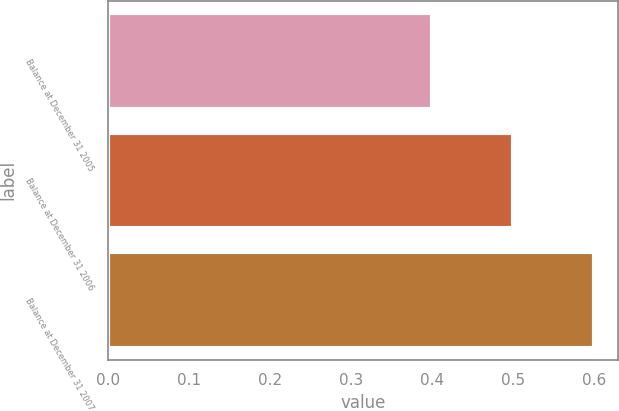Convert chart. <chart><loc_0><loc_0><loc_500><loc_500><bar_chart><fcel>Balance at December 31 2005<fcel>Balance at December 31 2006<fcel>Balance at December 31 2007<nl><fcel>0.4<fcel>0.5<fcel>0.6<nl></chart> 